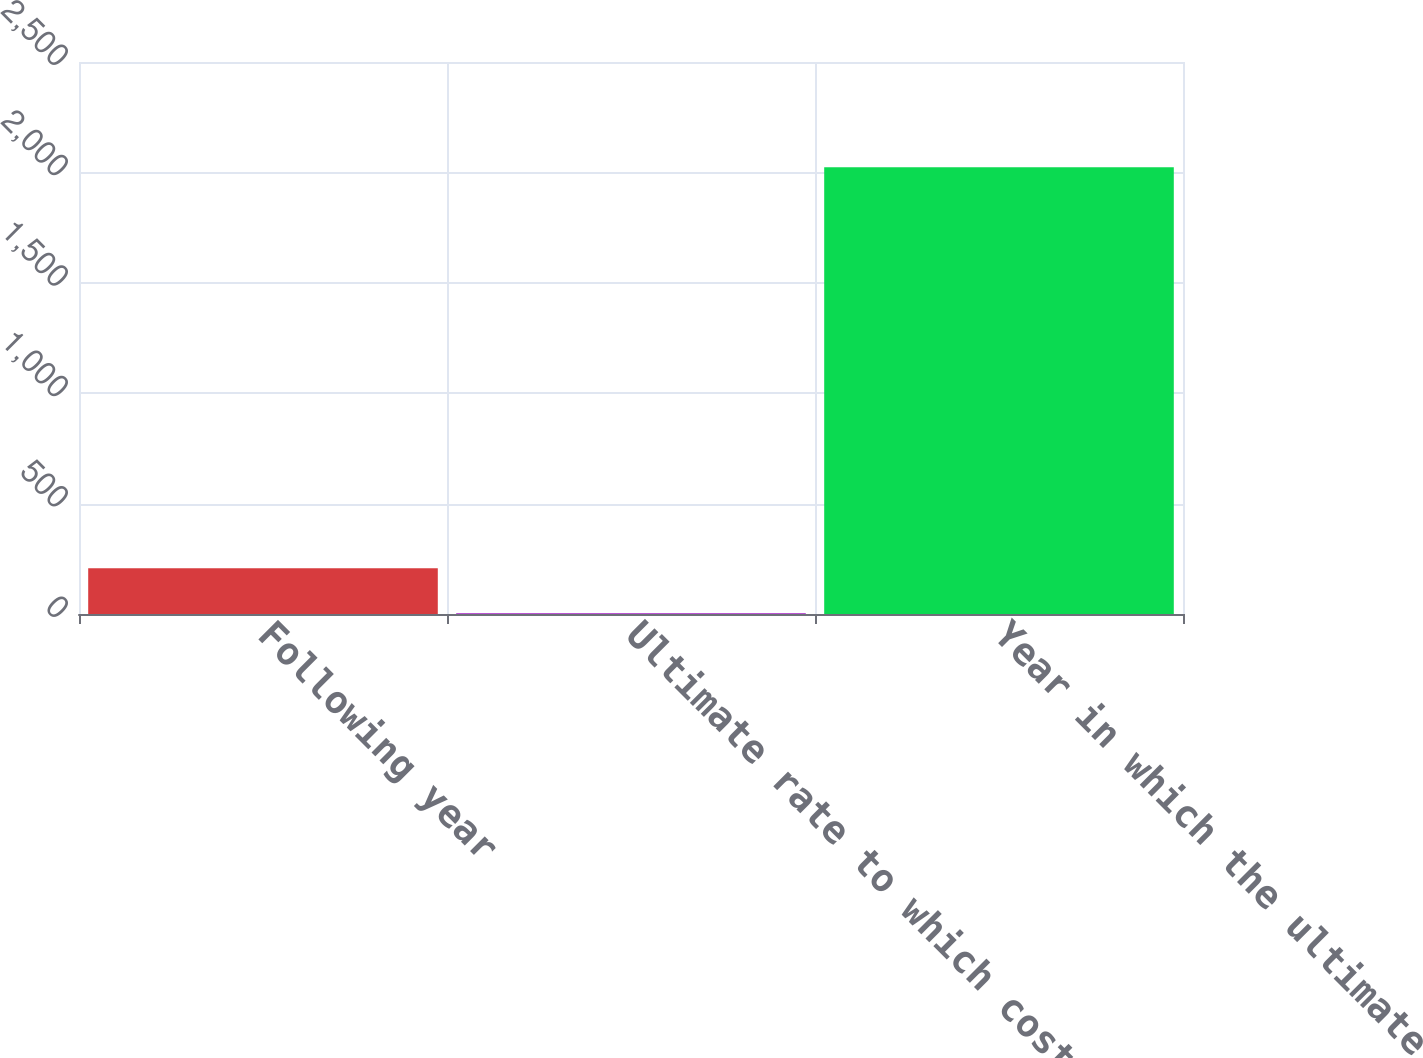<chart> <loc_0><loc_0><loc_500><loc_500><bar_chart><fcel>Following year<fcel>Ultimate rate to which cost<fcel>Year in which the ultimate<nl><fcel>206.8<fcel>5<fcel>2023<nl></chart> 